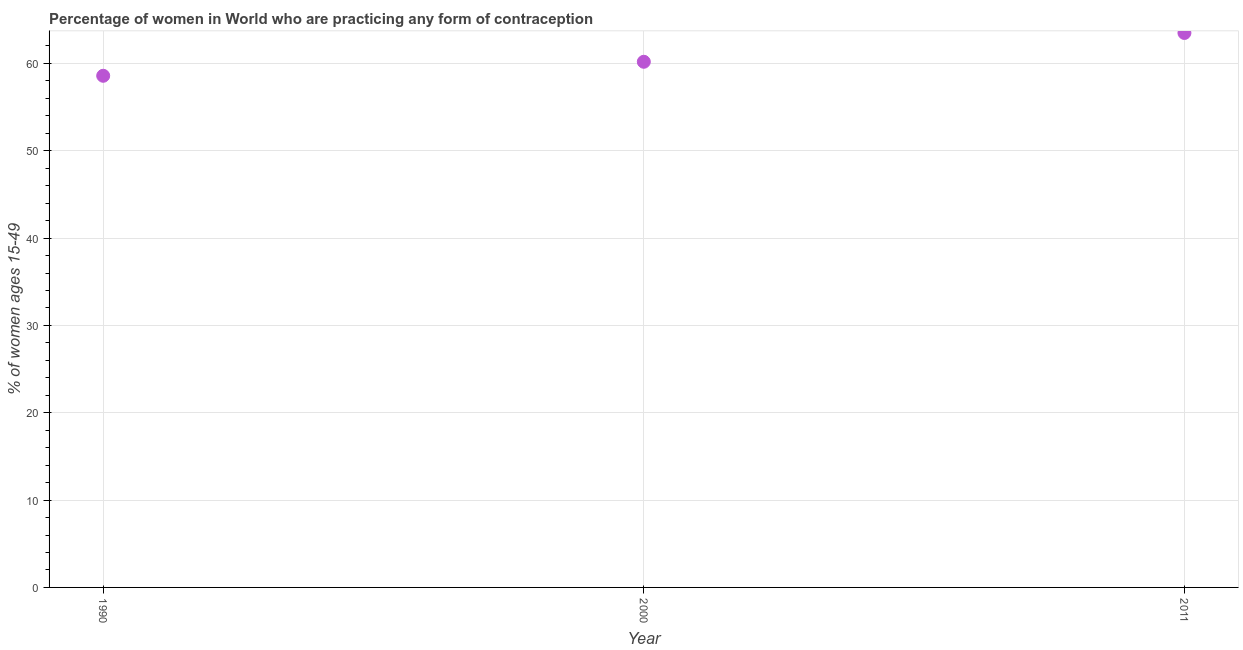What is the contraceptive prevalence in 2000?
Give a very brief answer. 60.19. Across all years, what is the maximum contraceptive prevalence?
Your response must be concise. 63.49. Across all years, what is the minimum contraceptive prevalence?
Your answer should be very brief. 58.58. In which year was the contraceptive prevalence maximum?
Offer a very short reply. 2011. What is the sum of the contraceptive prevalence?
Make the answer very short. 182.26. What is the difference between the contraceptive prevalence in 1990 and 2000?
Offer a terse response. -1.6. What is the average contraceptive prevalence per year?
Offer a terse response. 60.75. What is the median contraceptive prevalence?
Give a very brief answer. 60.19. What is the ratio of the contraceptive prevalence in 1990 to that in 2011?
Provide a succinct answer. 0.92. Is the difference between the contraceptive prevalence in 2000 and 2011 greater than the difference between any two years?
Offer a very short reply. No. What is the difference between the highest and the second highest contraceptive prevalence?
Your answer should be very brief. 3.3. What is the difference between the highest and the lowest contraceptive prevalence?
Make the answer very short. 4.9. How many years are there in the graph?
Ensure brevity in your answer.  3. Does the graph contain grids?
Keep it short and to the point. Yes. What is the title of the graph?
Your answer should be very brief. Percentage of women in World who are practicing any form of contraception. What is the label or title of the Y-axis?
Provide a succinct answer. % of women ages 15-49. What is the % of women ages 15-49 in 1990?
Your answer should be very brief. 58.58. What is the % of women ages 15-49 in 2000?
Your answer should be very brief. 60.19. What is the % of women ages 15-49 in 2011?
Your answer should be compact. 63.49. What is the difference between the % of women ages 15-49 in 1990 and 2000?
Offer a very short reply. -1.6. What is the difference between the % of women ages 15-49 in 1990 and 2011?
Your answer should be compact. -4.9. What is the difference between the % of women ages 15-49 in 2000 and 2011?
Make the answer very short. -3.3. What is the ratio of the % of women ages 15-49 in 1990 to that in 2011?
Provide a short and direct response. 0.92. What is the ratio of the % of women ages 15-49 in 2000 to that in 2011?
Your response must be concise. 0.95. 